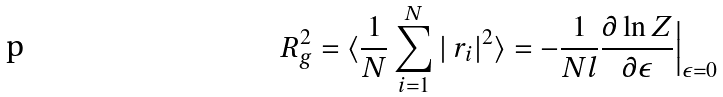<formula> <loc_0><loc_0><loc_500><loc_500>R _ { g } ^ { 2 } = \langle \frac { 1 } { N } \sum _ { i = 1 } ^ { N } | \ r _ { i } | ^ { 2 } \rangle = - \frac { 1 } { N l } \frac { \partial \ln Z } { \partial \epsilon } { \Big | } _ { \epsilon = 0 }</formula> 